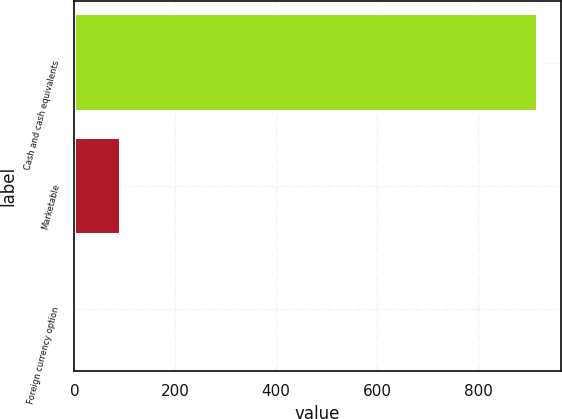Convert chart. <chart><loc_0><loc_0><loc_500><loc_500><bar_chart><fcel>Cash and cash equivalents<fcel>Marketable<fcel>Foreign currency option<nl><fcel>917.9<fcel>91.97<fcel>0.2<nl></chart> 